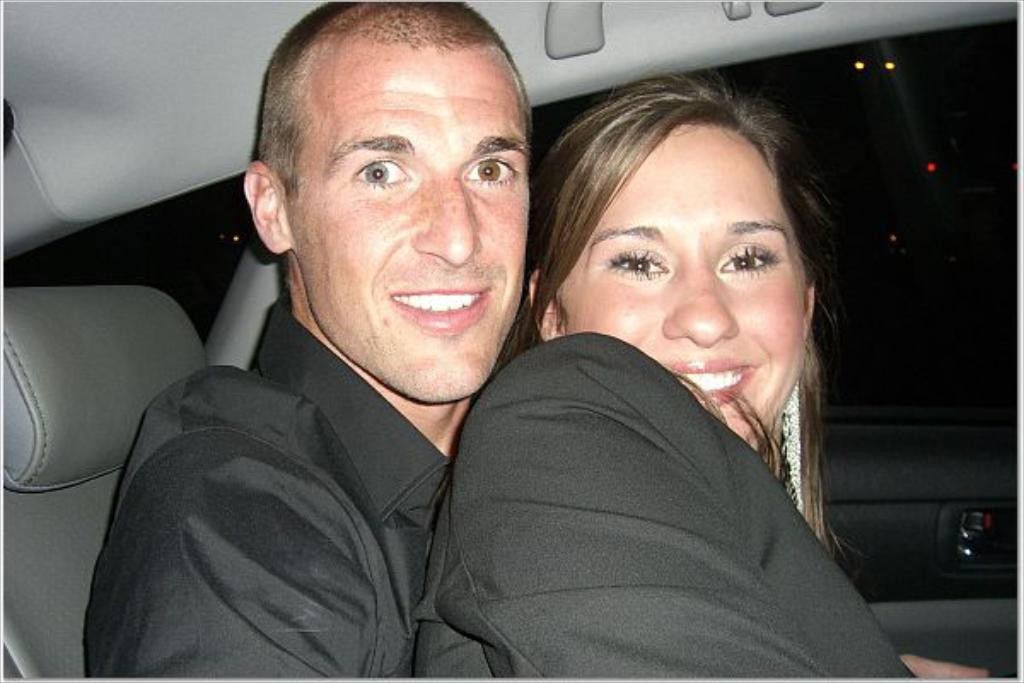What is the setting of the image? The image shows an inside view of a car. How many people are in the car? There are two persons in the car. What color are the outfits of the people in the image? Both persons are wearing black color dress. What is the facial expression of the people in the image? Both persons are smiling. What can be seen on the right side of the image? There are lights visible on the right side of the image. What type of yoke is being used to control the car in the image? There is no yoke present in the image, as cars are typically controlled using a steering wheel. 